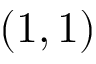Convert formula to latex. <formula><loc_0><loc_0><loc_500><loc_500>( 1 , 1 )</formula> 